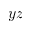Convert formula to latex. <formula><loc_0><loc_0><loc_500><loc_500>y z</formula> 